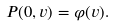<formula> <loc_0><loc_0><loc_500><loc_500>P ( 0 , v ) = \varphi ( v ) .</formula> 